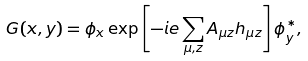Convert formula to latex. <formula><loc_0><loc_0><loc_500><loc_500>G ( { x } , { y } ) = \phi _ { x } \exp \left [ - i e \sum _ { \mu , { z } } A _ { \mu { z } } h _ { \mu { z } } \right ] \phi ^ { * } _ { y } ,</formula> 